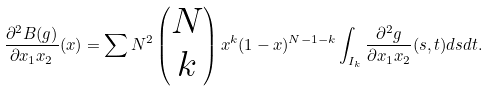Convert formula to latex. <formula><loc_0><loc_0><loc_500><loc_500>\frac { \partial ^ { 2 } B ( g ) } { \partial x _ { 1 } x _ { 2 } } ( x ) = \sum N ^ { 2 } \begin{pmatrix} N \\ k \end{pmatrix} x ^ { k } ( 1 - x ) ^ { N - 1 - k } \int _ { I _ { k } } \frac { \partial ^ { 2 } g } { \partial x _ { 1 } x _ { 2 } } ( s , t ) d s d t .</formula> 